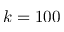<formula> <loc_0><loc_0><loc_500><loc_500>k = 1 0 0</formula> 